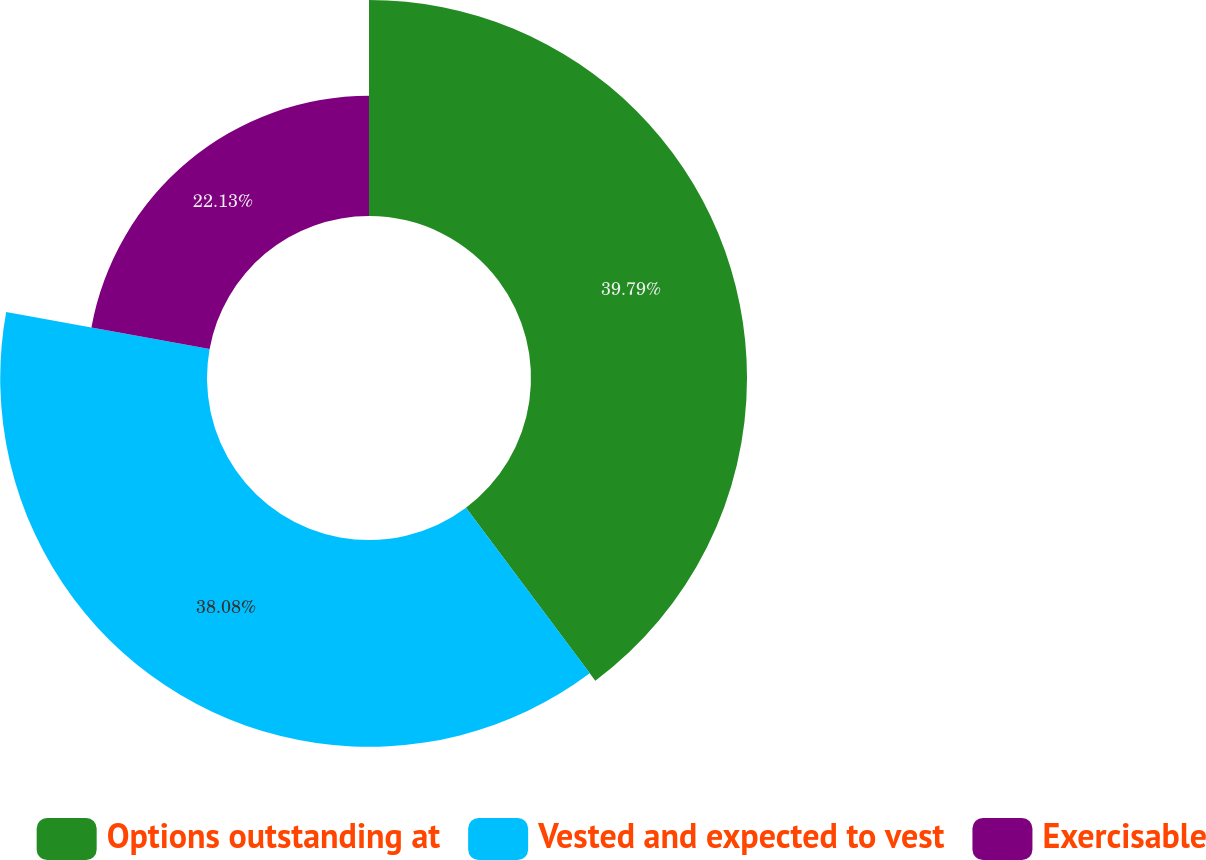Convert chart. <chart><loc_0><loc_0><loc_500><loc_500><pie_chart><fcel>Options outstanding at<fcel>Vested and expected to vest<fcel>Exercisable<nl><fcel>39.78%<fcel>38.08%<fcel>22.13%<nl></chart> 